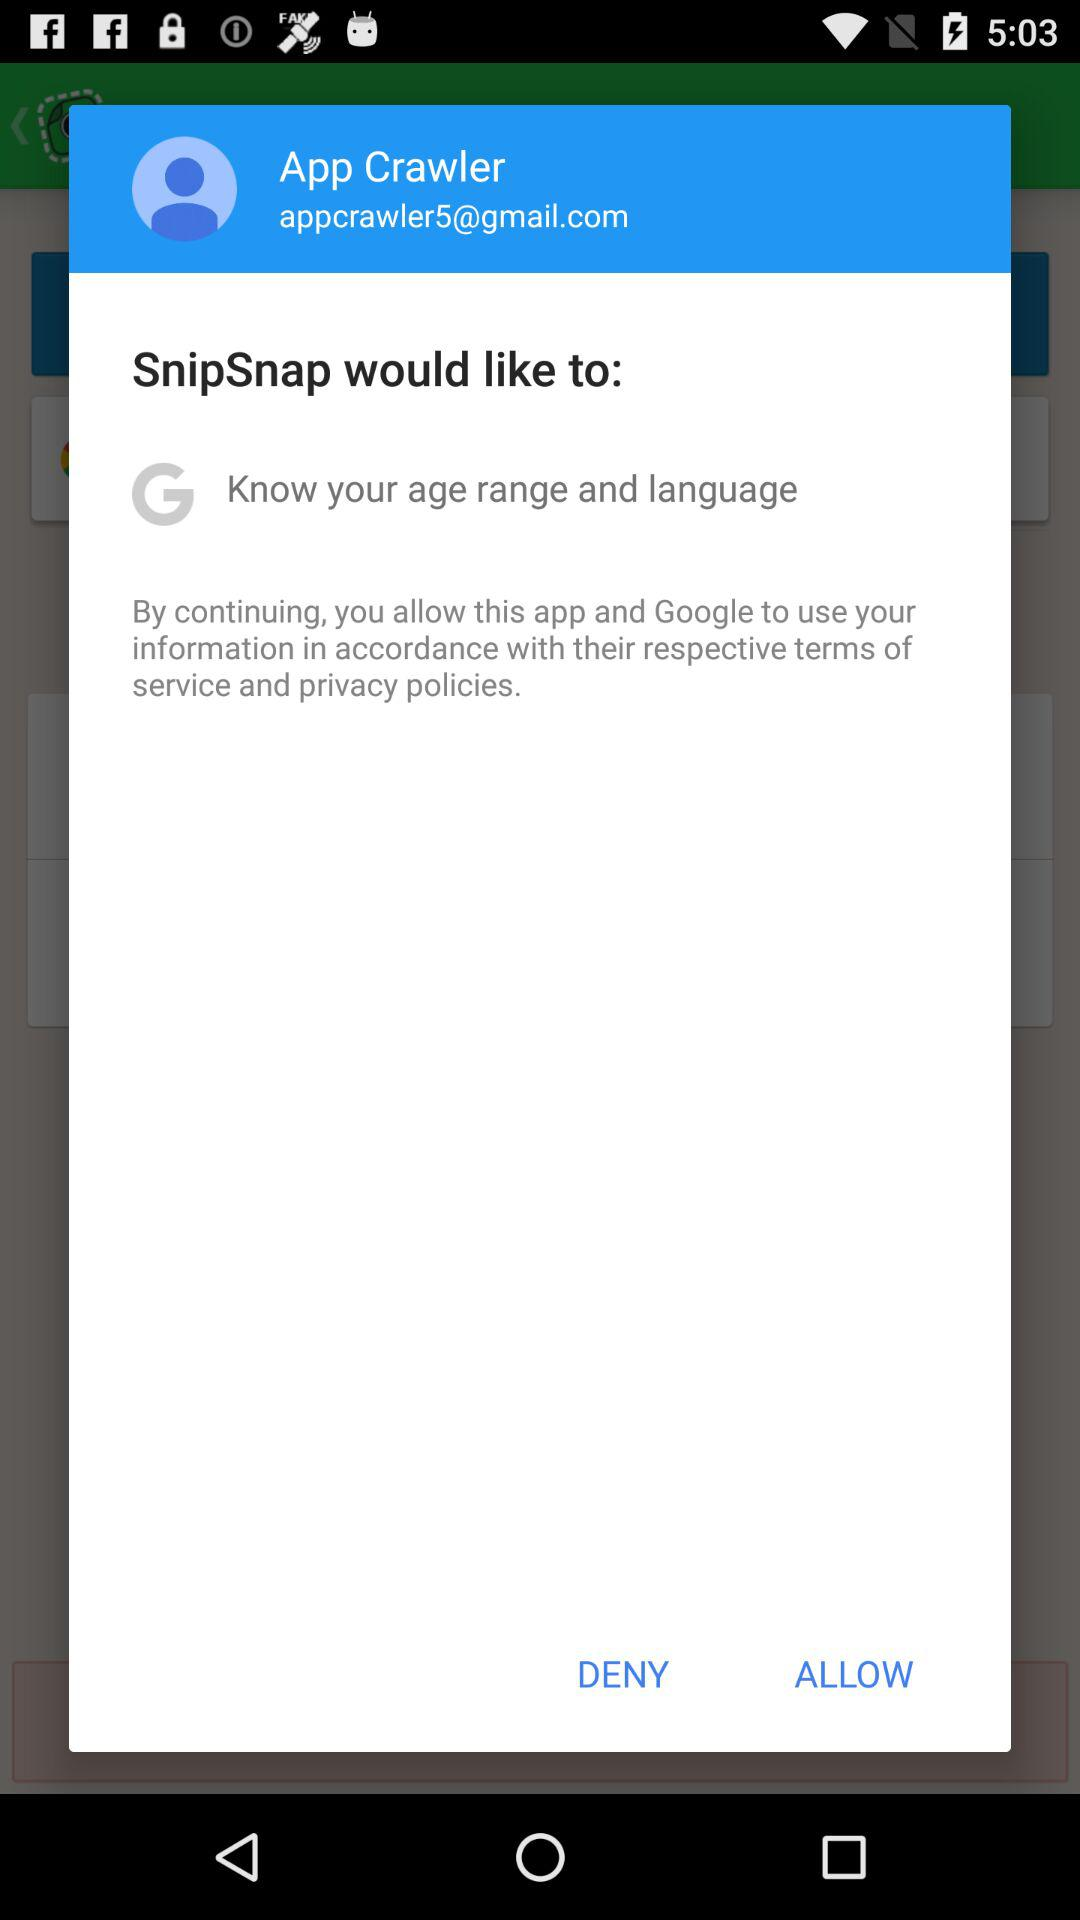What is the user's language?
When the provided information is insufficient, respond with <no answer>. <no answer> 